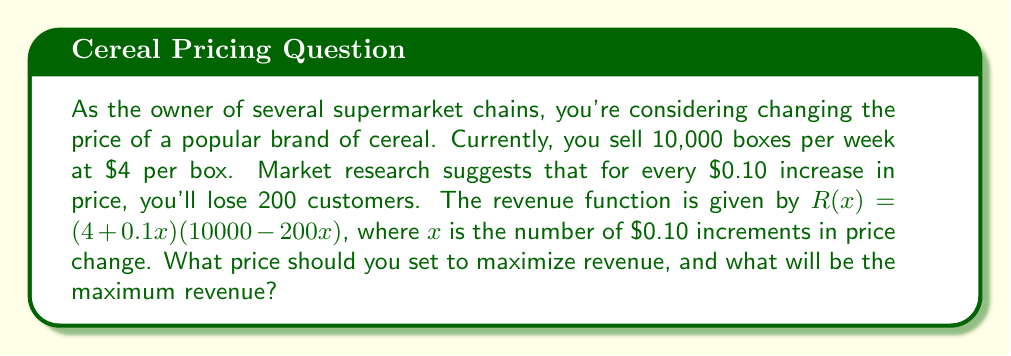Can you solve this math problem? To solve this problem, we'll use derivatives to find the maximum of the revenue function.

1) First, let's expand the revenue function:
   $R(x) = (4 + 0.1x)(10000 - 200x)$
   $R(x) = 40000 + 1000x - 800x - 20x^2$
   $R(x) = 40000 + 200x - 20x^2$

2) To find the maximum, we need to find where the derivative equals zero:
   $R'(x) = 200 - 40x$

3) Set $R'(x) = 0$ and solve for $x$:
   $200 - 40x = 0$
   $40x = 200$
   $x = 5$

4) To confirm this is a maximum, check the second derivative:
   $R''(x) = -40$, which is negative, confirming a maximum.

5) The optimal number of $0.10 increments is 5, so the price increase is $5 * $0.10 = $0.50.
   The new optimal price is $4 + $0.50 = $4.50.

6) Calculate the maximum revenue:
   $R(5) = 40000 + 200(5) - 20(5)^2$
   $R(5) = 40000 + 1000 - 500$
   $R(5) = 40500$

Therefore, the maximum revenue is $40,500 per week.
Answer: The optimal price to maximize revenue is $4.50 per box, and the maximum weekly revenue is $40,500. 